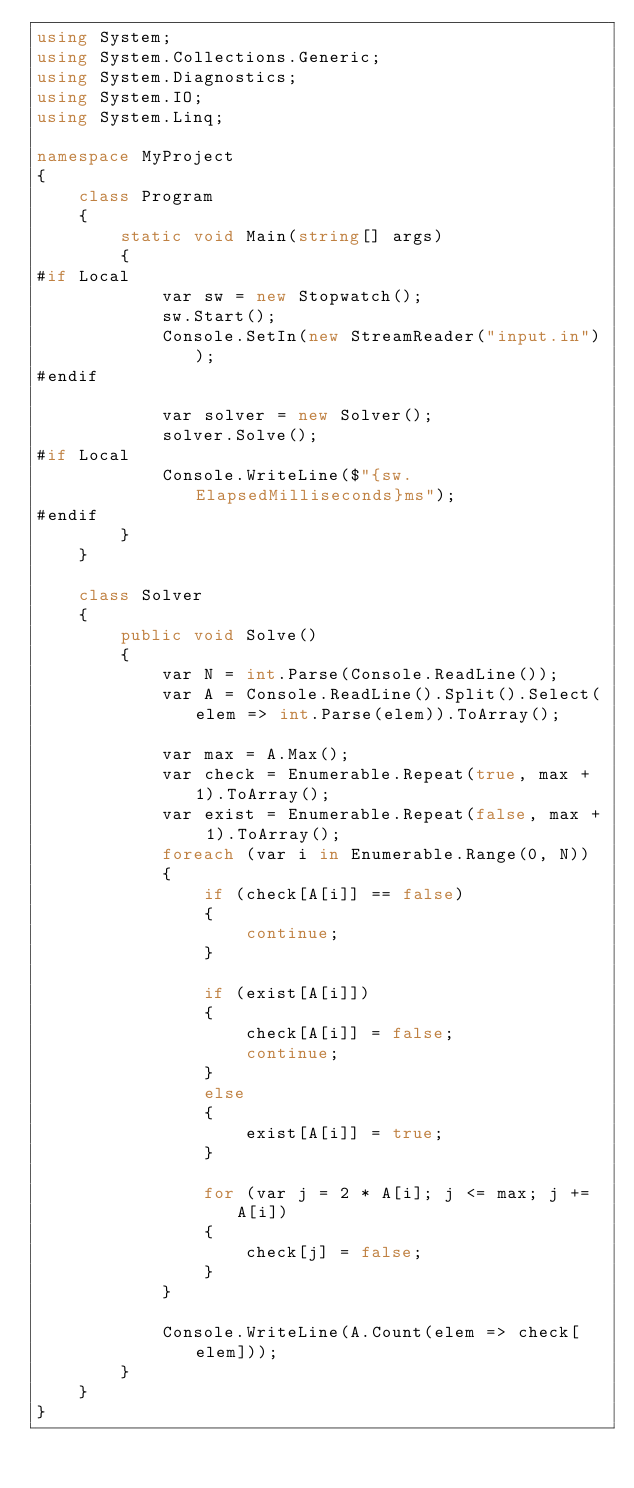<code> <loc_0><loc_0><loc_500><loc_500><_C#_>using System;
using System.Collections.Generic;
using System.Diagnostics;
using System.IO;
using System.Linq;

namespace MyProject
{
    class Program
    {
        static void Main(string[] args)
        {
#if Local
            var sw = new Stopwatch();
            sw.Start();
            Console.SetIn(new StreamReader("input.in"));
#endif

            var solver = new Solver();
            solver.Solve();
#if Local
            Console.WriteLine($"{sw.ElapsedMilliseconds}ms");
#endif
        }
    }

    class Solver
    {
        public void Solve()
        {
            var N = int.Parse(Console.ReadLine());
            var A = Console.ReadLine().Split().Select(elem => int.Parse(elem)).ToArray();

            var max = A.Max();
            var check = Enumerable.Repeat(true, max + 1).ToArray();
            var exist = Enumerable.Repeat(false, max + 1).ToArray();
            foreach (var i in Enumerable.Range(0, N))
            {
                if (check[A[i]] == false)
                {
                    continue;
                }

                if (exist[A[i]])
                {
                    check[A[i]] = false;
                    continue;
                }
                else
                {
                    exist[A[i]] = true;
                }

                for (var j = 2 * A[i]; j <= max; j += A[i])
                {
                    check[j] = false;
                }
            }

            Console.WriteLine(A.Count(elem => check[elem]));
        }
    }
}
</code> 